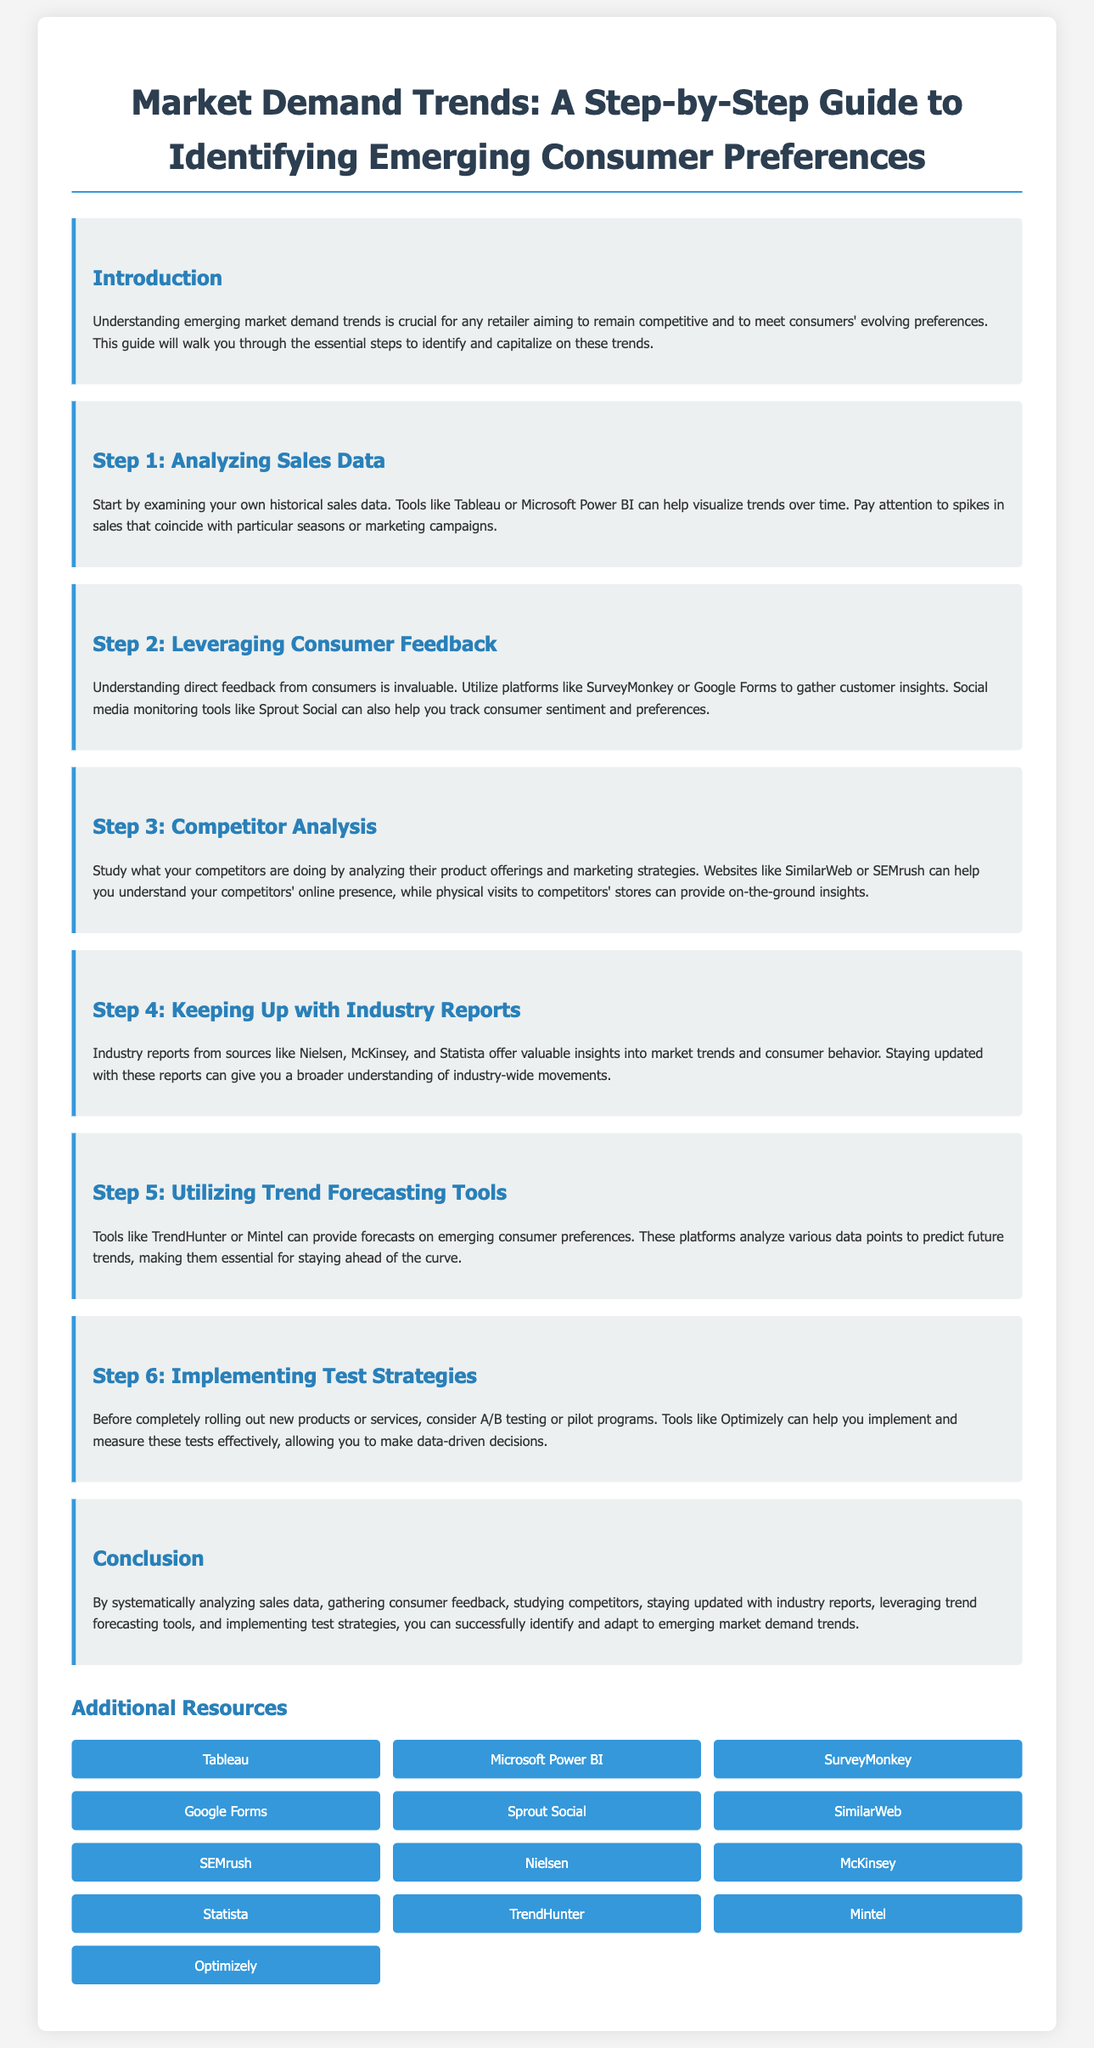what is the title of the document? The title is mentioned in the header of the document and serves as the heading.
Answer: Market Demand Trends: A Step-by-Step Guide to Identifying Emerging Consumer Preferences how many steps are outlined in the guide? The document lists each of the steps sequentially, with a clear breakdown of the process.
Answer: 6 which tool is suggested for analyzing sales data? The document specifies certain tools that can be used for visualizing trends in sales data.
Answer: Tableau what is the primary purpose of leveraging consumer feedback? The document explains the importance of consumer feedback specifically in the context of market trends.
Answer: Understanding direct feedback from consumers is invaluable which industry sources are recommended for keeping up with industry reports? The document lists sources that provide valuable insights into market trends and consumer behavior.
Answer: Nielsen, McKinsey, Statista what testing strategy is suggested before rolling out products? The document provides guidance on an approach to implement before launching new products or services.
Answer: A/B testing or pilot programs where can you find trend forecasting tools mentioned in the guide? The document identifies specific platforms that can provide forecasts on consumer preferences.
Answer: TrendHunter, Mintel what is the focus of Step 3 in the guide? The title of Step 3 clearly indicates what aspect of market demand it addresses within the document.
Answer: Competitor Analysis 